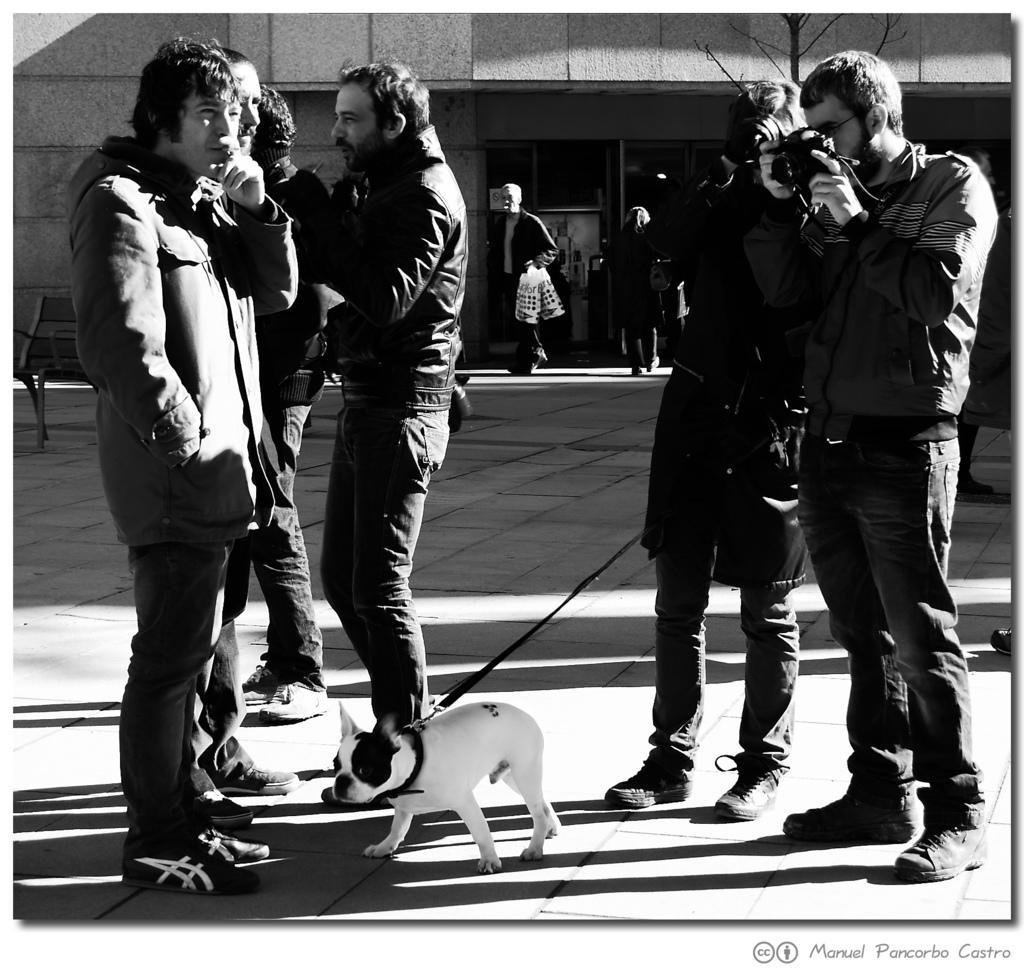In one or two sentences, can you explain what this image depicts? In this image there are group of people standing together in which one of them is holding dog and other one is capturing with camera, behind them there is a building where other people are standing. 